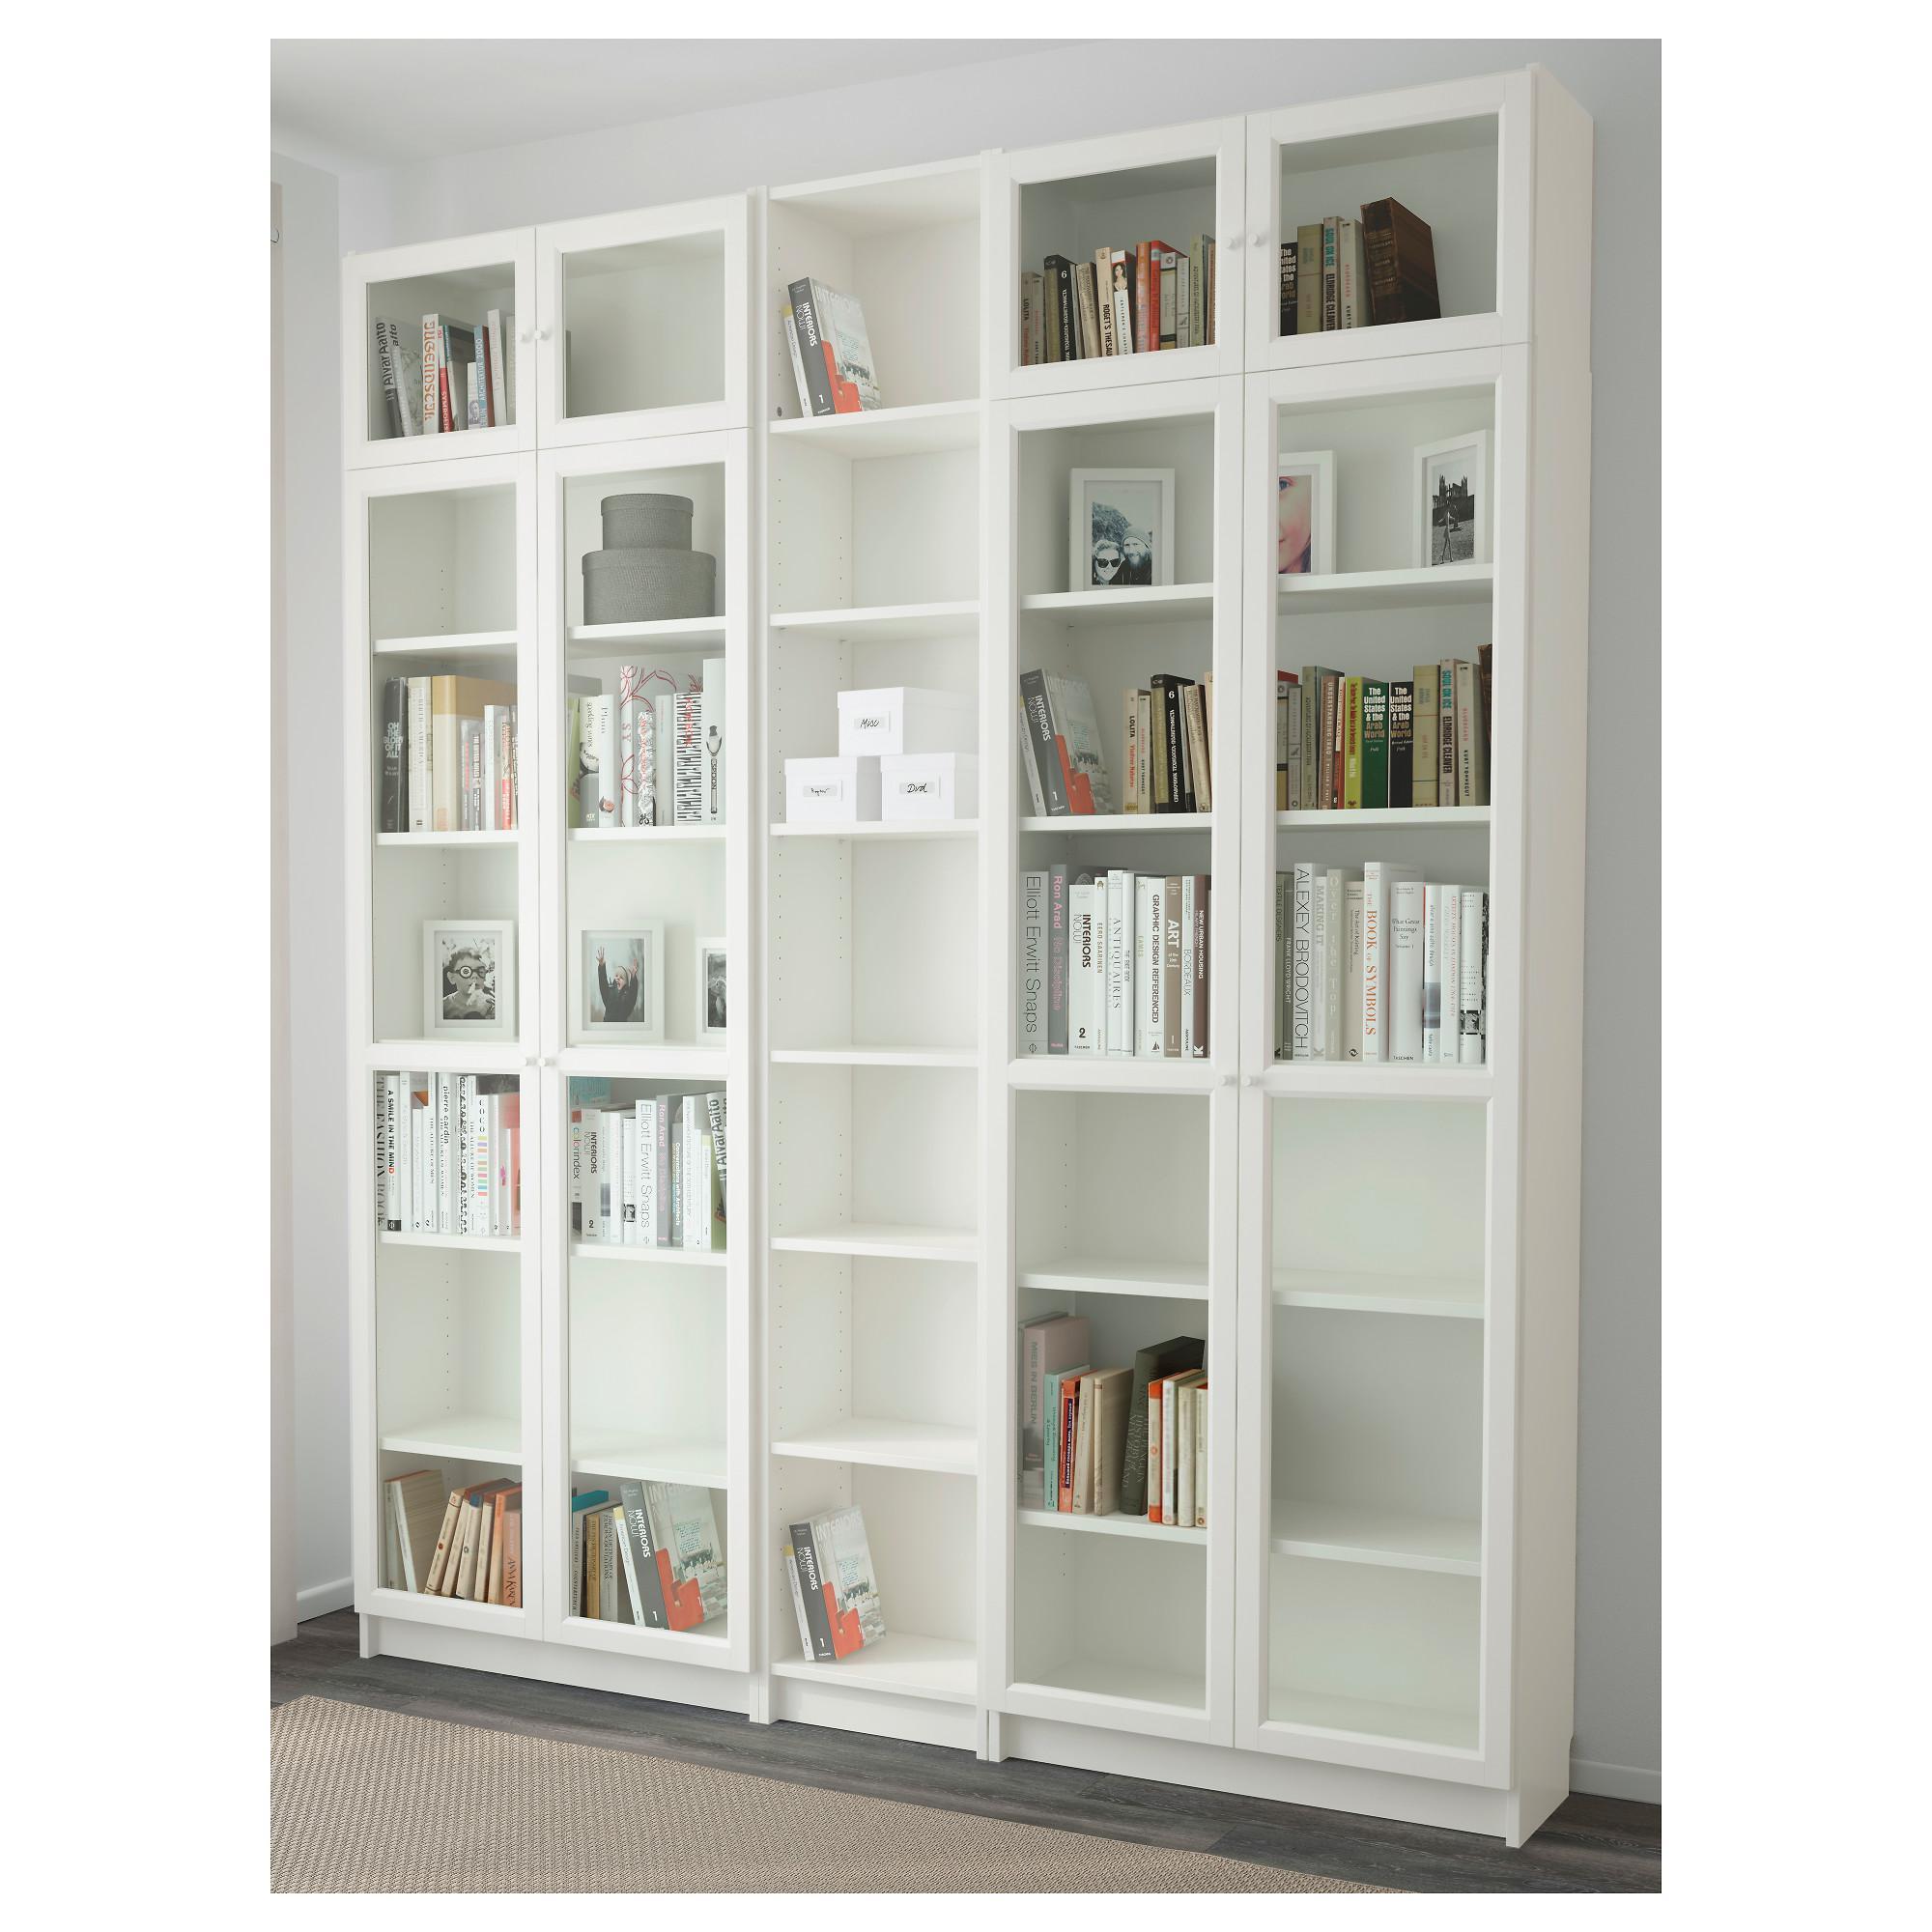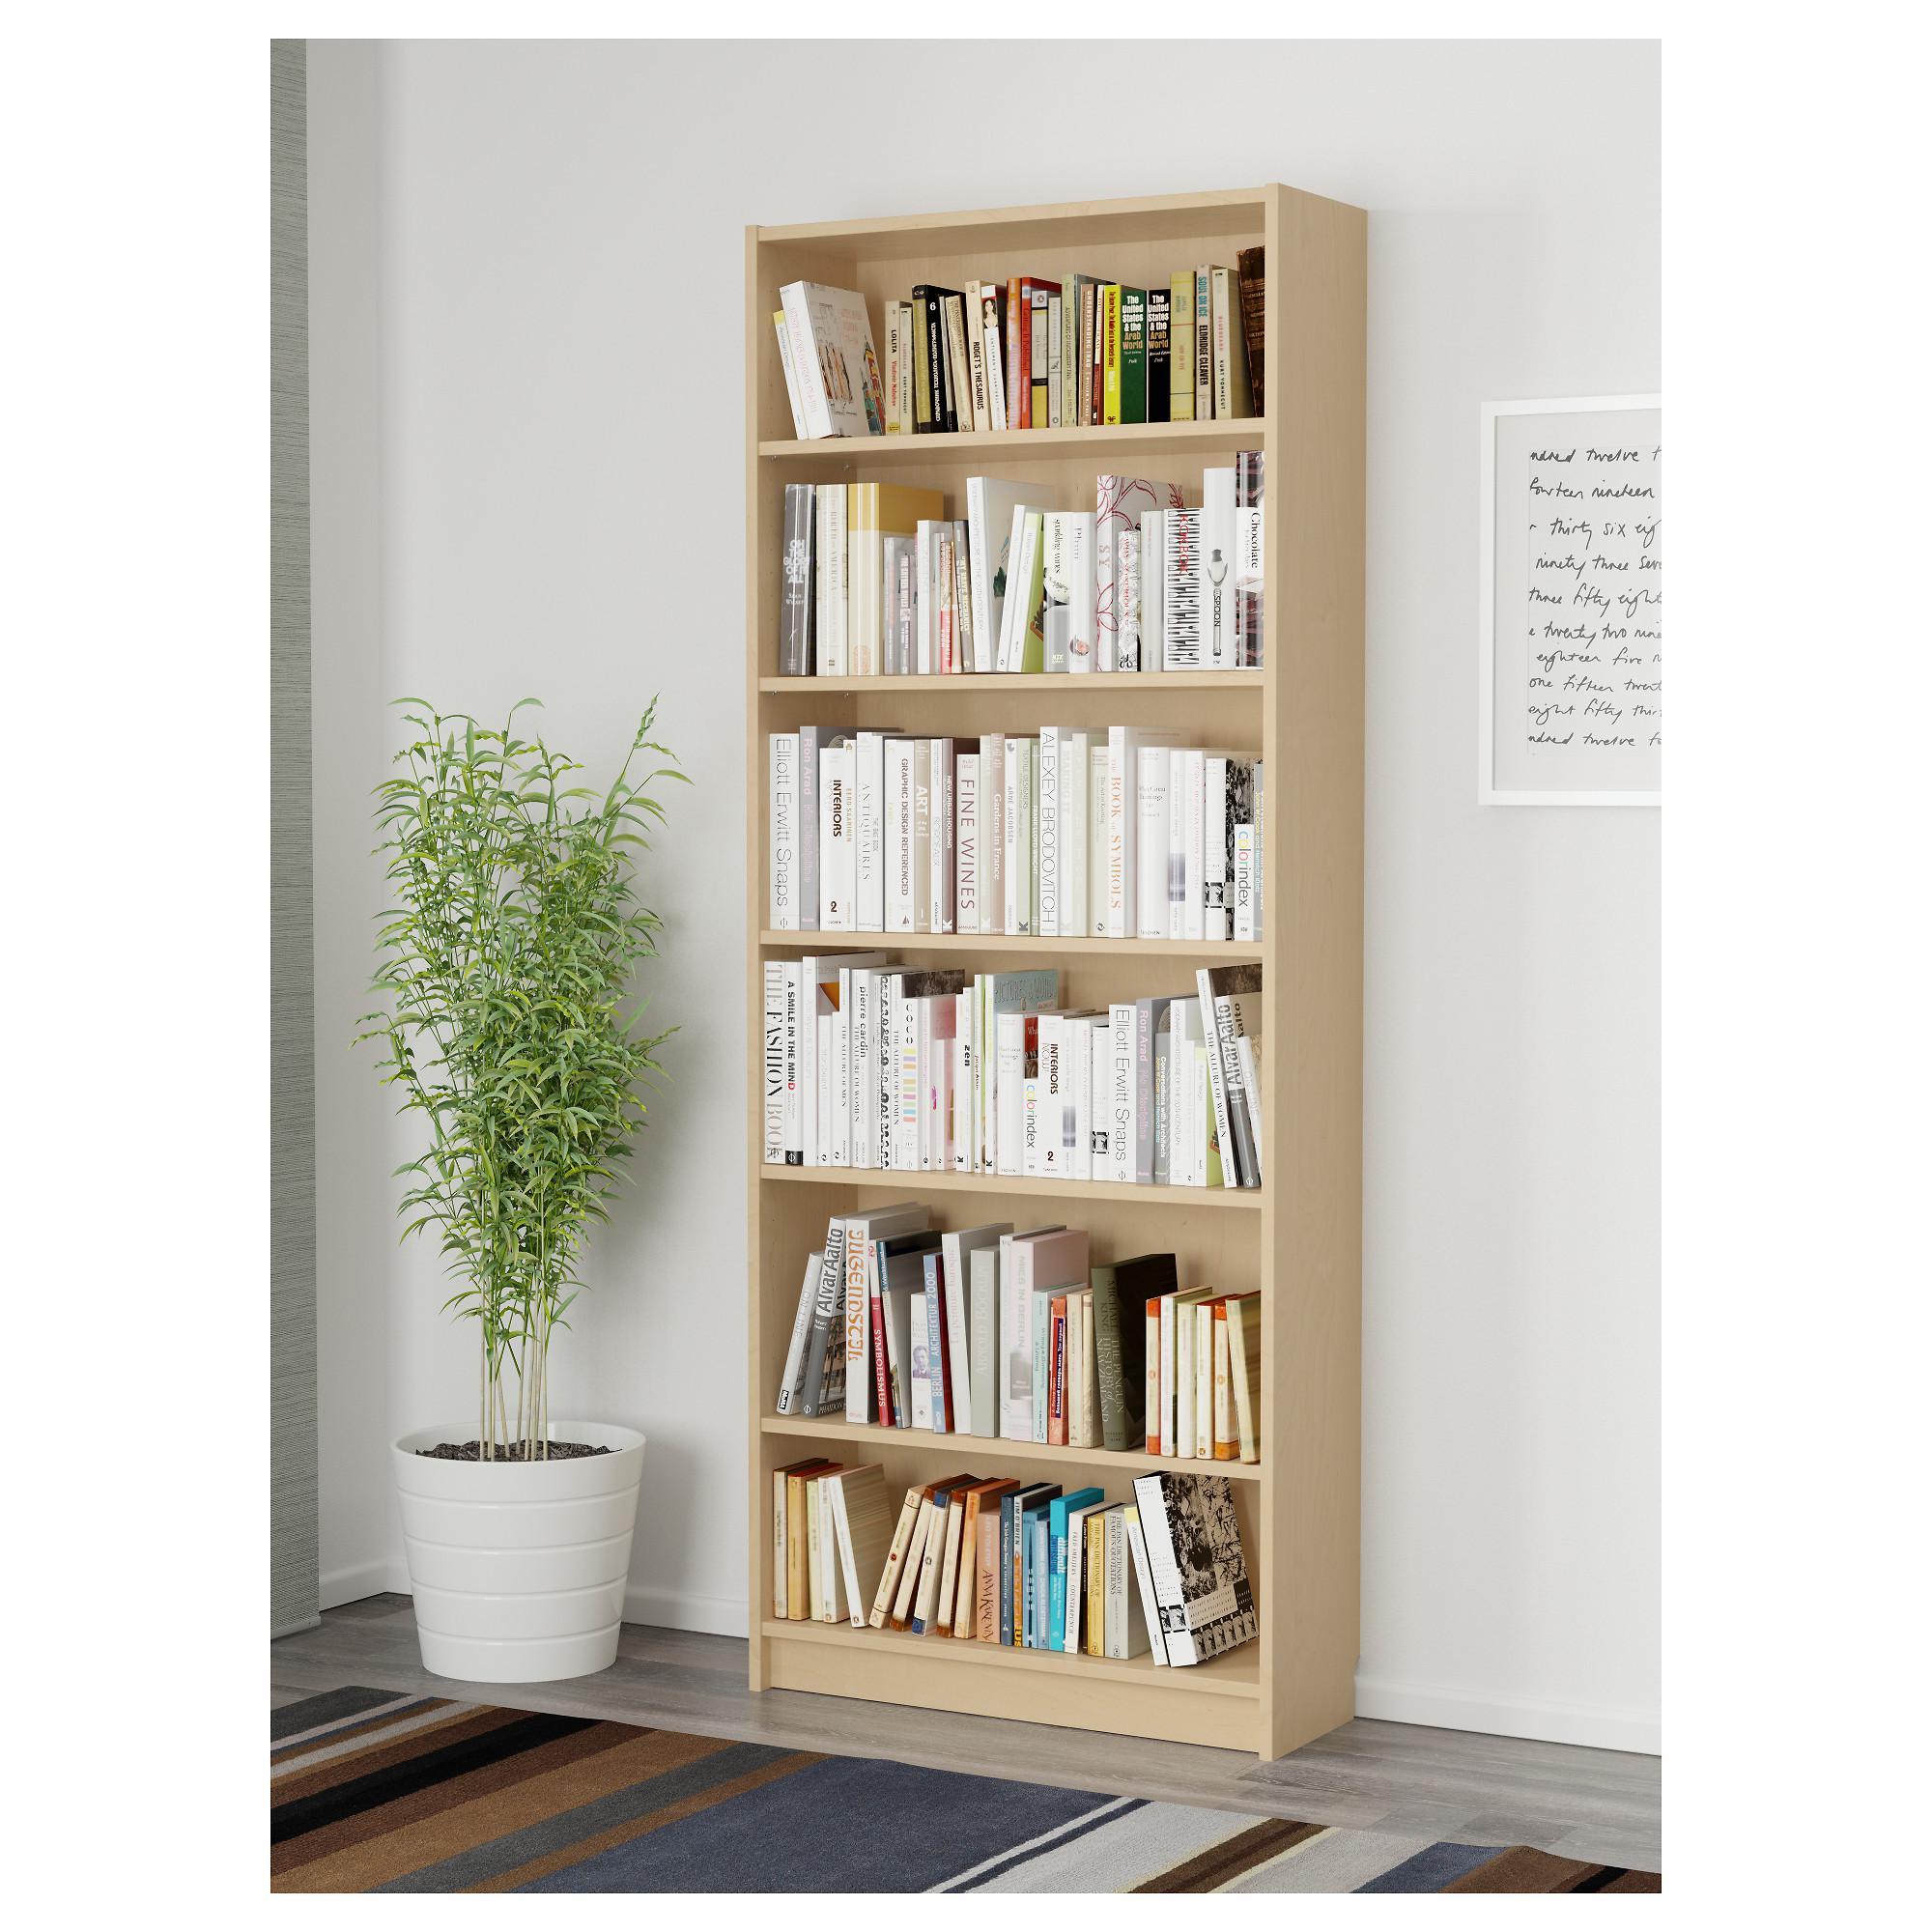The first image is the image on the left, the second image is the image on the right. For the images displayed, is the sentence "At least one of the images shows an empty bookcase." factually correct? Answer yes or no. No. 